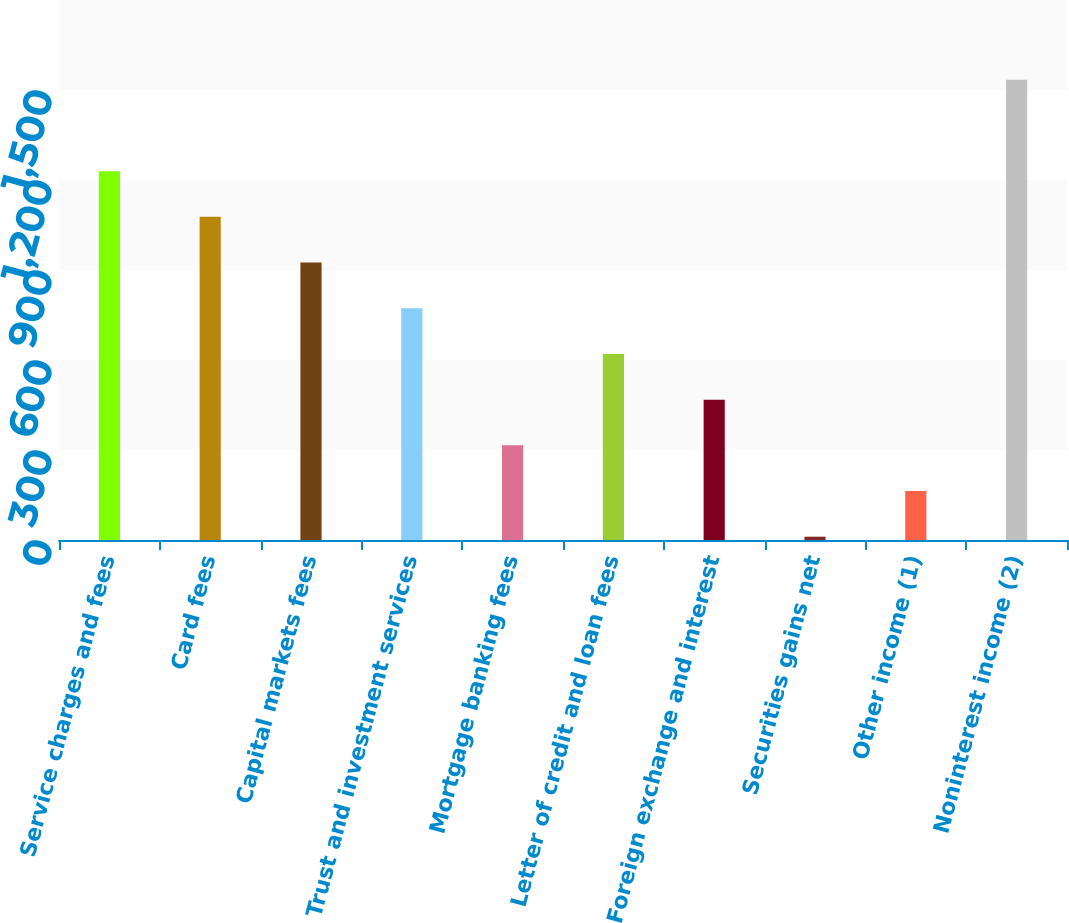Convert chart to OTSL. <chart><loc_0><loc_0><loc_500><loc_500><bar_chart><fcel>Service charges and fees<fcel>Card fees<fcel>Capital markets fees<fcel>Trust and investment services<fcel>Mortgage banking fees<fcel>Letter of credit and loan fees<fcel>Foreign exchange and interest<fcel>Securities gains net<fcel>Other income (1)<fcel>Noninterest income (2)<nl><fcel>1229.4<fcel>1077.1<fcel>924.8<fcel>772.5<fcel>315.6<fcel>620.2<fcel>467.9<fcel>11<fcel>163.3<fcel>1534<nl></chart> 